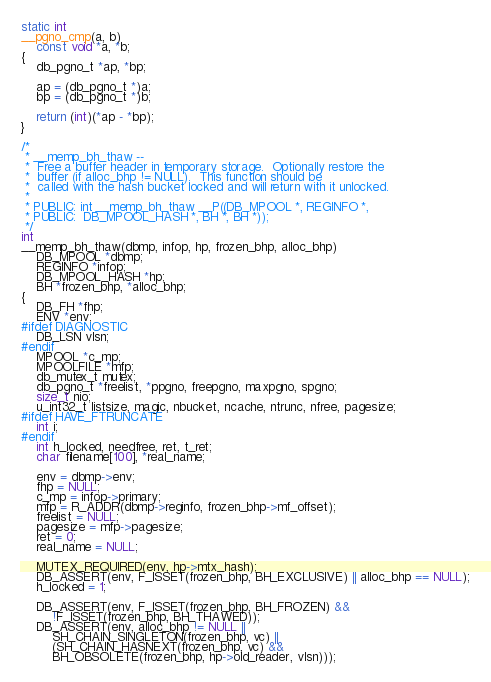Convert code to text. <code><loc_0><loc_0><loc_500><loc_500><_C_>
static int
__pgno_cmp(a, b)
	const void *a, *b;
{
	db_pgno_t *ap, *bp;

	ap = (db_pgno_t *)a;
	bp = (db_pgno_t *)b;

	return (int)(*ap - *bp);
}

/*
 * __memp_bh_thaw --
 *	Free a buffer header in temporary storage.  Optionally restore the
 *	buffer (if alloc_bhp != NULL).  This function should be
 *	called with the hash bucket locked and will return with it unlocked.
 *
 * PUBLIC: int __memp_bh_thaw __P((DB_MPOOL *, REGINFO *,
 * PUBLIC:	DB_MPOOL_HASH *, BH *, BH *));
 */
int
__memp_bh_thaw(dbmp, infop, hp, frozen_bhp, alloc_bhp)
	DB_MPOOL *dbmp;
	REGINFO *infop;
	DB_MPOOL_HASH *hp;
	BH *frozen_bhp, *alloc_bhp;
{
	DB_FH *fhp;
	ENV *env;
#ifdef DIAGNOSTIC
	DB_LSN vlsn;
#endif
	MPOOL *c_mp;
	MPOOLFILE *mfp;
	db_mutex_t mutex;
	db_pgno_t *freelist, *ppgno, freepgno, maxpgno, spgno;
	size_t nio;
	u_int32_t listsize, magic, nbucket, ncache, ntrunc, nfree, pagesize;
#ifdef HAVE_FTRUNCATE
	int i;
#endif
	int h_locked, needfree, ret, t_ret;
	char filename[100], *real_name;

	env = dbmp->env;
	fhp = NULL;
	c_mp = infop->primary;
	mfp = R_ADDR(dbmp->reginfo, frozen_bhp->mf_offset);
	freelist = NULL;
	pagesize = mfp->pagesize;
	ret = 0;
	real_name = NULL;

	MUTEX_REQUIRED(env, hp->mtx_hash);
	DB_ASSERT(env, F_ISSET(frozen_bhp, BH_EXCLUSIVE) || alloc_bhp == NULL);
	h_locked = 1;

	DB_ASSERT(env, F_ISSET(frozen_bhp, BH_FROZEN) &&
	    !F_ISSET(frozen_bhp, BH_THAWED));
	DB_ASSERT(env, alloc_bhp != NULL ||
	    SH_CHAIN_SINGLETON(frozen_bhp, vc) ||
	    (SH_CHAIN_HASNEXT(frozen_bhp, vc) &&
	    BH_OBSOLETE(frozen_bhp, hp->old_reader, vlsn)));</code> 